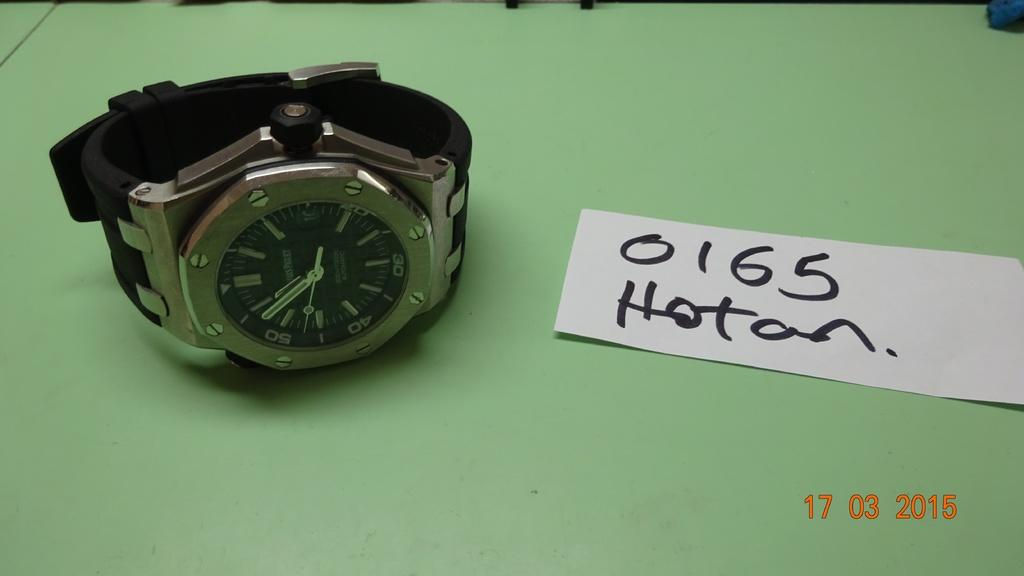Provide a one-sentence caption for the provided image. A watch sits on a green table next to a card that reads 0165 Hotan. 